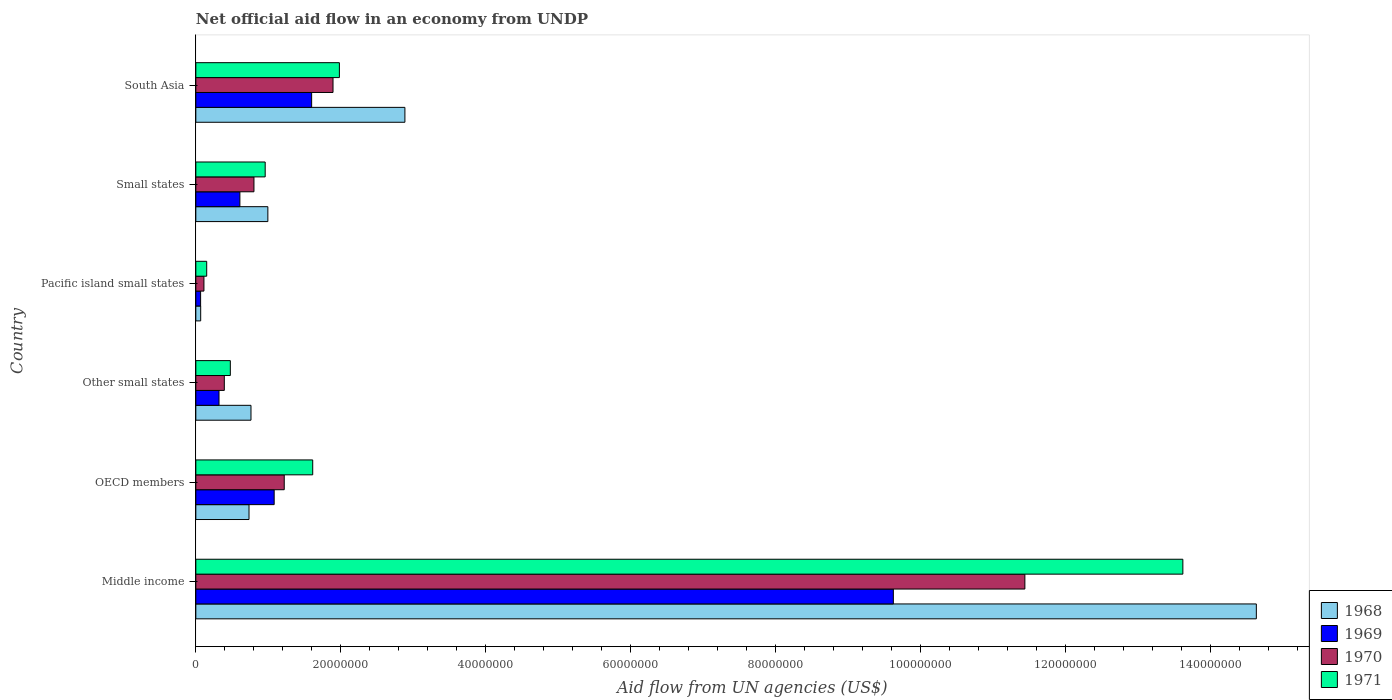How many different coloured bars are there?
Offer a terse response. 4. How many groups of bars are there?
Offer a terse response. 6. Are the number of bars per tick equal to the number of legend labels?
Make the answer very short. Yes. Are the number of bars on each tick of the Y-axis equal?
Make the answer very short. Yes. How many bars are there on the 2nd tick from the bottom?
Keep it short and to the point. 4. What is the label of the 5th group of bars from the top?
Your answer should be very brief. OECD members. What is the net official aid flow in 1968 in OECD members?
Your answer should be compact. 7.34e+06. Across all countries, what is the maximum net official aid flow in 1968?
Provide a succinct answer. 1.46e+08. Across all countries, what is the minimum net official aid flow in 1968?
Your answer should be very brief. 6.70e+05. In which country was the net official aid flow in 1970 maximum?
Give a very brief answer. Middle income. In which country was the net official aid flow in 1969 minimum?
Offer a very short reply. Pacific island small states. What is the total net official aid flow in 1971 in the graph?
Provide a short and direct response. 1.88e+08. What is the difference between the net official aid flow in 1970 in OECD members and that in Other small states?
Offer a terse response. 8.27e+06. What is the difference between the net official aid flow in 1971 in Pacific island small states and the net official aid flow in 1970 in Middle income?
Offer a very short reply. -1.13e+08. What is the average net official aid flow in 1970 per country?
Your answer should be compact. 2.64e+07. What is the difference between the net official aid flow in 1971 and net official aid flow in 1968 in Small states?
Provide a succinct answer. -3.70e+05. What is the ratio of the net official aid flow in 1969 in Pacific island small states to that in South Asia?
Your answer should be compact. 0.04. Is the net official aid flow in 1968 in OECD members less than that in Small states?
Give a very brief answer. Yes. Is the difference between the net official aid flow in 1971 in OECD members and Pacific island small states greater than the difference between the net official aid flow in 1968 in OECD members and Pacific island small states?
Your answer should be very brief. Yes. What is the difference between the highest and the second highest net official aid flow in 1971?
Give a very brief answer. 1.16e+08. What is the difference between the highest and the lowest net official aid flow in 1968?
Make the answer very short. 1.46e+08. In how many countries, is the net official aid flow in 1968 greater than the average net official aid flow in 1968 taken over all countries?
Make the answer very short. 1. Is the sum of the net official aid flow in 1969 in Other small states and Pacific island small states greater than the maximum net official aid flow in 1968 across all countries?
Your response must be concise. No. What does the 2nd bar from the bottom in Middle income represents?
Ensure brevity in your answer.  1969. Is it the case that in every country, the sum of the net official aid flow in 1971 and net official aid flow in 1970 is greater than the net official aid flow in 1968?
Give a very brief answer. Yes. What is the difference between two consecutive major ticks on the X-axis?
Your answer should be very brief. 2.00e+07. Does the graph contain any zero values?
Make the answer very short. No. Does the graph contain grids?
Ensure brevity in your answer.  No. Where does the legend appear in the graph?
Your response must be concise. Bottom right. How many legend labels are there?
Offer a terse response. 4. What is the title of the graph?
Offer a very short reply. Net official aid flow in an economy from UNDP. What is the label or title of the X-axis?
Keep it short and to the point. Aid flow from UN agencies (US$). What is the label or title of the Y-axis?
Keep it short and to the point. Country. What is the Aid flow from UN agencies (US$) of 1968 in Middle income?
Provide a succinct answer. 1.46e+08. What is the Aid flow from UN agencies (US$) of 1969 in Middle income?
Ensure brevity in your answer.  9.62e+07. What is the Aid flow from UN agencies (US$) of 1970 in Middle income?
Give a very brief answer. 1.14e+08. What is the Aid flow from UN agencies (US$) of 1971 in Middle income?
Keep it short and to the point. 1.36e+08. What is the Aid flow from UN agencies (US$) of 1968 in OECD members?
Offer a terse response. 7.34e+06. What is the Aid flow from UN agencies (US$) in 1969 in OECD members?
Provide a succinct answer. 1.08e+07. What is the Aid flow from UN agencies (US$) of 1970 in OECD members?
Provide a short and direct response. 1.22e+07. What is the Aid flow from UN agencies (US$) of 1971 in OECD members?
Offer a terse response. 1.61e+07. What is the Aid flow from UN agencies (US$) in 1968 in Other small states?
Give a very brief answer. 7.61e+06. What is the Aid flow from UN agencies (US$) in 1969 in Other small states?
Your answer should be compact. 3.20e+06. What is the Aid flow from UN agencies (US$) in 1970 in Other small states?
Keep it short and to the point. 3.93e+06. What is the Aid flow from UN agencies (US$) of 1971 in Other small states?
Provide a succinct answer. 4.76e+06. What is the Aid flow from UN agencies (US$) of 1968 in Pacific island small states?
Ensure brevity in your answer.  6.70e+05. What is the Aid flow from UN agencies (US$) of 1970 in Pacific island small states?
Provide a succinct answer. 1.12e+06. What is the Aid flow from UN agencies (US$) of 1971 in Pacific island small states?
Your response must be concise. 1.50e+06. What is the Aid flow from UN agencies (US$) in 1968 in Small states?
Offer a terse response. 9.94e+06. What is the Aid flow from UN agencies (US$) in 1969 in Small states?
Provide a succinct answer. 6.08e+06. What is the Aid flow from UN agencies (US$) in 1970 in Small states?
Ensure brevity in your answer.  8.02e+06. What is the Aid flow from UN agencies (US$) in 1971 in Small states?
Provide a succinct answer. 9.57e+06. What is the Aid flow from UN agencies (US$) of 1968 in South Asia?
Your answer should be compact. 2.88e+07. What is the Aid flow from UN agencies (US$) in 1969 in South Asia?
Provide a succinct answer. 1.60e+07. What is the Aid flow from UN agencies (US$) in 1970 in South Asia?
Your answer should be compact. 1.89e+07. What is the Aid flow from UN agencies (US$) in 1971 in South Asia?
Make the answer very short. 1.98e+07. Across all countries, what is the maximum Aid flow from UN agencies (US$) in 1968?
Provide a succinct answer. 1.46e+08. Across all countries, what is the maximum Aid flow from UN agencies (US$) in 1969?
Ensure brevity in your answer.  9.62e+07. Across all countries, what is the maximum Aid flow from UN agencies (US$) of 1970?
Ensure brevity in your answer.  1.14e+08. Across all countries, what is the maximum Aid flow from UN agencies (US$) of 1971?
Make the answer very short. 1.36e+08. Across all countries, what is the minimum Aid flow from UN agencies (US$) in 1968?
Offer a very short reply. 6.70e+05. Across all countries, what is the minimum Aid flow from UN agencies (US$) in 1969?
Your answer should be very brief. 6.60e+05. Across all countries, what is the minimum Aid flow from UN agencies (US$) in 1970?
Give a very brief answer. 1.12e+06. Across all countries, what is the minimum Aid flow from UN agencies (US$) of 1971?
Your answer should be compact. 1.50e+06. What is the total Aid flow from UN agencies (US$) of 1968 in the graph?
Your answer should be compact. 2.01e+08. What is the total Aid flow from UN agencies (US$) of 1969 in the graph?
Offer a very short reply. 1.33e+08. What is the total Aid flow from UN agencies (US$) in 1970 in the graph?
Your answer should be compact. 1.59e+08. What is the total Aid flow from UN agencies (US$) in 1971 in the graph?
Your response must be concise. 1.88e+08. What is the difference between the Aid flow from UN agencies (US$) of 1968 in Middle income and that in OECD members?
Provide a short and direct response. 1.39e+08. What is the difference between the Aid flow from UN agencies (US$) of 1969 in Middle income and that in OECD members?
Give a very brief answer. 8.54e+07. What is the difference between the Aid flow from UN agencies (US$) of 1970 in Middle income and that in OECD members?
Give a very brief answer. 1.02e+08. What is the difference between the Aid flow from UN agencies (US$) of 1971 in Middle income and that in OECD members?
Make the answer very short. 1.20e+08. What is the difference between the Aid flow from UN agencies (US$) of 1968 in Middle income and that in Other small states?
Offer a terse response. 1.39e+08. What is the difference between the Aid flow from UN agencies (US$) in 1969 in Middle income and that in Other small states?
Give a very brief answer. 9.30e+07. What is the difference between the Aid flow from UN agencies (US$) of 1970 in Middle income and that in Other small states?
Ensure brevity in your answer.  1.10e+08. What is the difference between the Aid flow from UN agencies (US$) in 1971 in Middle income and that in Other small states?
Keep it short and to the point. 1.31e+08. What is the difference between the Aid flow from UN agencies (US$) in 1968 in Middle income and that in Pacific island small states?
Offer a very short reply. 1.46e+08. What is the difference between the Aid flow from UN agencies (US$) of 1969 in Middle income and that in Pacific island small states?
Keep it short and to the point. 9.56e+07. What is the difference between the Aid flow from UN agencies (US$) of 1970 in Middle income and that in Pacific island small states?
Keep it short and to the point. 1.13e+08. What is the difference between the Aid flow from UN agencies (US$) in 1971 in Middle income and that in Pacific island small states?
Offer a terse response. 1.35e+08. What is the difference between the Aid flow from UN agencies (US$) in 1968 in Middle income and that in Small states?
Your answer should be compact. 1.36e+08. What is the difference between the Aid flow from UN agencies (US$) in 1969 in Middle income and that in Small states?
Ensure brevity in your answer.  9.02e+07. What is the difference between the Aid flow from UN agencies (US$) in 1970 in Middle income and that in Small states?
Provide a short and direct response. 1.06e+08. What is the difference between the Aid flow from UN agencies (US$) in 1971 in Middle income and that in Small states?
Offer a terse response. 1.27e+08. What is the difference between the Aid flow from UN agencies (US$) in 1968 in Middle income and that in South Asia?
Your answer should be very brief. 1.17e+08. What is the difference between the Aid flow from UN agencies (US$) in 1969 in Middle income and that in South Asia?
Make the answer very short. 8.03e+07. What is the difference between the Aid flow from UN agencies (US$) of 1970 in Middle income and that in South Asia?
Your answer should be very brief. 9.55e+07. What is the difference between the Aid flow from UN agencies (US$) of 1971 in Middle income and that in South Asia?
Your answer should be compact. 1.16e+08. What is the difference between the Aid flow from UN agencies (US$) of 1969 in OECD members and that in Other small states?
Provide a succinct answer. 7.61e+06. What is the difference between the Aid flow from UN agencies (US$) in 1970 in OECD members and that in Other small states?
Offer a very short reply. 8.27e+06. What is the difference between the Aid flow from UN agencies (US$) in 1971 in OECD members and that in Other small states?
Your answer should be compact. 1.14e+07. What is the difference between the Aid flow from UN agencies (US$) of 1968 in OECD members and that in Pacific island small states?
Ensure brevity in your answer.  6.67e+06. What is the difference between the Aid flow from UN agencies (US$) in 1969 in OECD members and that in Pacific island small states?
Offer a very short reply. 1.02e+07. What is the difference between the Aid flow from UN agencies (US$) of 1970 in OECD members and that in Pacific island small states?
Offer a terse response. 1.11e+07. What is the difference between the Aid flow from UN agencies (US$) of 1971 in OECD members and that in Pacific island small states?
Your answer should be compact. 1.46e+07. What is the difference between the Aid flow from UN agencies (US$) in 1968 in OECD members and that in Small states?
Your answer should be very brief. -2.60e+06. What is the difference between the Aid flow from UN agencies (US$) in 1969 in OECD members and that in Small states?
Provide a succinct answer. 4.73e+06. What is the difference between the Aid flow from UN agencies (US$) in 1970 in OECD members and that in Small states?
Your answer should be very brief. 4.18e+06. What is the difference between the Aid flow from UN agencies (US$) of 1971 in OECD members and that in Small states?
Offer a terse response. 6.56e+06. What is the difference between the Aid flow from UN agencies (US$) in 1968 in OECD members and that in South Asia?
Provide a succinct answer. -2.15e+07. What is the difference between the Aid flow from UN agencies (US$) in 1969 in OECD members and that in South Asia?
Your answer should be very brief. -5.17e+06. What is the difference between the Aid flow from UN agencies (US$) in 1970 in OECD members and that in South Asia?
Your answer should be very brief. -6.73e+06. What is the difference between the Aid flow from UN agencies (US$) of 1971 in OECD members and that in South Asia?
Provide a short and direct response. -3.68e+06. What is the difference between the Aid flow from UN agencies (US$) of 1968 in Other small states and that in Pacific island small states?
Your answer should be compact. 6.94e+06. What is the difference between the Aid flow from UN agencies (US$) of 1969 in Other small states and that in Pacific island small states?
Make the answer very short. 2.54e+06. What is the difference between the Aid flow from UN agencies (US$) of 1970 in Other small states and that in Pacific island small states?
Your answer should be very brief. 2.81e+06. What is the difference between the Aid flow from UN agencies (US$) of 1971 in Other small states and that in Pacific island small states?
Make the answer very short. 3.26e+06. What is the difference between the Aid flow from UN agencies (US$) in 1968 in Other small states and that in Small states?
Your answer should be compact. -2.33e+06. What is the difference between the Aid flow from UN agencies (US$) in 1969 in Other small states and that in Small states?
Offer a very short reply. -2.88e+06. What is the difference between the Aid flow from UN agencies (US$) of 1970 in Other small states and that in Small states?
Provide a short and direct response. -4.09e+06. What is the difference between the Aid flow from UN agencies (US$) in 1971 in Other small states and that in Small states?
Provide a succinct answer. -4.81e+06. What is the difference between the Aid flow from UN agencies (US$) in 1968 in Other small states and that in South Asia?
Ensure brevity in your answer.  -2.12e+07. What is the difference between the Aid flow from UN agencies (US$) in 1969 in Other small states and that in South Asia?
Ensure brevity in your answer.  -1.28e+07. What is the difference between the Aid flow from UN agencies (US$) in 1970 in Other small states and that in South Asia?
Give a very brief answer. -1.50e+07. What is the difference between the Aid flow from UN agencies (US$) in 1971 in Other small states and that in South Asia?
Your answer should be compact. -1.50e+07. What is the difference between the Aid flow from UN agencies (US$) of 1968 in Pacific island small states and that in Small states?
Ensure brevity in your answer.  -9.27e+06. What is the difference between the Aid flow from UN agencies (US$) in 1969 in Pacific island small states and that in Small states?
Your answer should be compact. -5.42e+06. What is the difference between the Aid flow from UN agencies (US$) in 1970 in Pacific island small states and that in Small states?
Make the answer very short. -6.90e+06. What is the difference between the Aid flow from UN agencies (US$) of 1971 in Pacific island small states and that in Small states?
Give a very brief answer. -8.07e+06. What is the difference between the Aid flow from UN agencies (US$) in 1968 in Pacific island small states and that in South Asia?
Offer a terse response. -2.82e+07. What is the difference between the Aid flow from UN agencies (US$) in 1969 in Pacific island small states and that in South Asia?
Give a very brief answer. -1.53e+07. What is the difference between the Aid flow from UN agencies (US$) in 1970 in Pacific island small states and that in South Asia?
Give a very brief answer. -1.78e+07. What is the difference between the Aid flow from UN agencies (US$) in 1971 in Pacific island small states and that in South Asia?
Provide a succinct answer. -1.83e+07. What is the difference between the Aid flow from UN agencies (US$) in 1968 in Small states and that in South Asia?
Your answer should be compact. -1.89e+07. What is the difference between the Aid flow from UN agencies (US$) in 1969 in Small states and that in South Asia?
Keep it short and to the point. -9.90e+06. What is the difference between the Aid flow from UN agencies (US$) of 1970 in Small states and that in South Asia?
Give a very brief answer. -1.09e+07. What is the difference between the Aid flow from UN agencies (US$) in 1971 in Small states and that in South Asia?
Provide a succinct answer. -1.02e+07. What is the difference between the Aid flow from UN agencies (US$) of 1968 in Middle income and the Aid flow from UN agencies (US$) of 1969 in OECD members?
Provide a succinct answer. 1.36e+08. What is the difference between the Aid flow from UN agencies (US$) in 1968 in Middle income and the Aid flow from UN agencies (US$) in 1970 in OECD members?
Your answer should be very brief. 1.34e+08. What is the difference between the Aid flow from UN agencies (US$) in 1968 in Middle income and the Aid flow from UN agencies (US$) in 1971 in OECD members?
Offer a very short reply. 1.30e+08. What is the difference between the Aid flow from UN agencies (US$) of 1969 in Middle income and the Aid flow from UN agencies (US$) of 1970 in OECD members?
Provide a short and direct response. 8.40e+07. What is the difference between the Aid flow from UN agencies (US$) of 1969 in Middle income and the Aid flow from UN agencies (US$) of 1971 in OECD members?
Keep it short and to the point. 8.01e+07. What is the difference between the Aid flow from UN agencies (US$) of 1970 in Middle income and the Aid flow from UN agencies (US$) of 1971 in OECD members?
Give a very brief answer. 9.83e+07. What is the difference between the Aid flow from UN agencies (US$) of 1968 in Middle income and the Aid flow from UN agencies (US$) of 1969 in Other small states?
Provide a succinct answer. 1.43e+08. What is the difference between the Aid flow from UN agencies (US$) in 1968 in Middle income and the Aid flow from UN agencies (US$) in 1970 in Other small states?
Your response must be concise. 1.42e+08. What is the difference between the Aid flow from UN agencies (US$) in 1968 in Middle income and the Aid flow from UN agencies (US$) in 1971 in Other small states?
Provide a short and direct response. 1.42e+08. What is the difference between the Aid flow from UN agencies (US$) of 1969 in Middle income and the Aid flow from UN agencies (US$) of 1970 in Other small states?
Provide a short and direct response. 9.23e+07. What is the difference between the Aid flow from UN agencies (US$) of 1969 in Middle income and the Aid flow from UN agencies (US$) of 1971 in Other small states?
Keep it short and to the point. 9.15e+07. What is the difference between the Aid flow from UN agencies (US$) of 1970 in Middle income and the Aid flow from UN agencies (US$) of 1971 in Other small states?
Provide a succinct answer. 1.10e+08. What is the difference between the Aid flow from UN agencies (US$) in 1968 in Middle income and the Aid flow from UN agencies (US$) in 1969 in Pacific island small states?
Your answer should be very brief. 1.46e+08. What is the difference between the Aid flow from UN agencies (US$) in 1968 in Middle income and the Aid flow from UN agencies (US$) in 1970 in Pacific island small states?
Make the answer very short. 1.45e+08. What is the difference between the Aid flow from UN agencies (US$) of 1968 in Middle income and the Aid flow from UN agencies (US$) of 1971 in Pacific island small states?
Offer a very short reply. 1.45e+08. What is the difference between the Aid flow from UN agencies (US$) of 1969 in Middle income and the Aid flow from UN agencies (US$) of 1970 in Pacific island small states?
Ensure brevity in your answer.  9.51e+07. What is the difference between the Aid flow from UN agencies (US$) in 1969 in Middle income and the Aid flow from UN agencies (US$) in 1971 in Pacific island small states?
Offer a very short reply. 9.48e+07. What is the difference between the Aid flow from UN agencies (US$) in 1970 in Middle income and the Aid flow from UN agencies (US$) in 1971 in Pacific island small states?
Your response must be concise. 1.13e+08. What is the difference between the Aid flow from UN agencies (US$) in 1968 in Middle income and the Aid flow from UN agencies (US$) in 1969 in Small states?
Your answer should be compact. 1.40e+08. What is the difference between the Aid flow from UN agencies (US$) in 1968 in Middle income and the Aid flow from UN agencies (US$) in 1970 in Small states?
Ensure brevity in your answer.  1.38e+08. What is the difference between the Aid flow from UN agencies (US$) of 1968 in Middle income and the Aid flow from UN agencies (US$) of 1971 in Small states?
Offer a very short reply. 1.37e+08. What is the difference between the Aid flow from UN agencies (US$) of 1969 in Middle income and the Aid flow from UN agencies (US$) of 1970 in Small states?
Provide a succinct answer. 8.82e+07. What is the difference between the Aid flow from UN agencies (US$) of 1969 in Middle income and the Aid flow from UN agencies (US$) of 1971 in Small states?
Your response must be concise. 8.67e+07. What is the difference between the Aid flow from UN agencies (US$) in 1970 in Middle income and the Aid flow from UN agencies (US$) in 1971 in Small states?
Offer a terse response. 1.05e+08. What is the difference between the Aid flow from UN agencies (US$) of 1968 in Middle income and the Aid flow from UN agencies (US$) of 1969 in South Asia?
Provide a short and direct response. 1.30e+08. What is the difference between the Aid flow from UN agencies (US$) of 1968 in Middle income and the Aid flow from UN agencies (US$) of 1970 in South Asia?
Provide a succinct answer. 1.27e+08. What is the difference between the Aid flow from UN agencies (US$) of 1968 in Middle income and the Aid flow from UN agencies (US$) of 1971 in South Asia?
Your response must be concise. 1.27e+08. What is the difference between the Aid flow from UN agencies (US$) of 1969 in Middle income and the Aid flow from UN agencies (US$) of 1970 in South Asia?
Offer a very short reply. 7.73e+07. What is the difference between the Aid flow from UN agencies (US$) of 1969 in Middle income and the Aid flow from UN agencies (US$) of 1971 in South Asia?
Offer a very short reply. 7.64e+07. What is the difference between the Aid flow from UN agencies (US$) of 1970 in Middle income and the Aid flow from UN agencies (US$) of 1971 in South Asia?
Ensure brevity in your answer.  9.46e+07. What is the difference between the Aid flow from UN agencies (US$) in 1968 in OECD members and the Aid flow from UN agencies (US$) in 1969 in Other small states?
Ensure brevity in your answer.  4.14e+06. What is the difference between the Aid flow from UN agencies (US$) of 1968 in OECD members and the Aid flow from UN agencies (US$) of 1970 in Other small states?
Offer a terse response. 3.41e+06. What is the difference between the Aid flow from UN agencies (US$) of 1968 in OECD members and the Aid flow from UN agencies (US$) of 1971 in Other small states?
Keep it short and to the point. 2.58e+06. What is the difference between the Aid flow from UN agencies (US$) of 1969 in OECD members and the Aid flow from UN agencies (US$) of 1970 in Other small states?
Your answer should be very brief. 6.88e+06. What is the difference between the Aid flow from UN agencies (US$) in 1969 in OECD members and the Aid flow from UN agencies (US$) in 1971 in Other small states?
Make the answer very short. 6.05e+06. What is the difference between the Aid flow from UN agencies (US$) of 1970 in OECD members and the Aid flow from UN agencies (US$) of 1971 in Other small states?
Your response must be concise. 7.44e+06. What is the difference between the Aid flow from UN agencies (US$) of 1968 in OECD members and the Aid flow from UN agencies (US$) of 1969 in Pacific island small states?
Ensure brevity in your answer.  6.68e+06. What is the difference between the Aid flow from UN agencies (US$) in 1968 in OECD members and the Aid flow from UN agencies (US$) in 1970 in Pacific island small states?
Offer a terse response. 6.22e+06. What is the difference between the Aid flow from UN agencies (US$) of 1968 in OECD members and the Aid flow from UN agencies (US$) of 1971 in Pacific island small states?
Offer a terse response. 5.84e+06. What is the difference between the Aid flow from UN agencies (US$) of 1969 in OECD members and the Aid flow from UN agencies (US$) of 1970 in Pacific island small states?
Your response must be concise. 9.69e+06. What is the difference between the Aid flow from UN agencies (US$) of 1969 in OECD members and the Aid flow from UN agencies (US$) of 1971 in Pacific island small states?
Offer a very short reply. 9.31e+06. What is the difference between the Aid flow from UN agencies (US$) of 1970 in OECD members and the Aid flow from UN agencies (US$) of 1971 in Pacific island small states?
Offer a very short reply. 1.07e+07. What is the difference between the Aid flow from UN agencies (US$) in 1968 in OECD members and the Aid flow from UN agencies (US$) in 1969 in Small states?
Provide a short and direct response. 1.26e+06. What is the difference between the Aid flow from UN agencies (US$) of 1968 in OECD members and the Aid flow from UN agencies (US$) of 1970 in Small states?
Provide a short and direct response. -6.80e+05. What is the difference between the Aid flow from UN agencies (US$) of 1968 in OECD members and the Aid flow from UN agencies (US$) of 1971 in Small states?
Provide a succinct answer. -2.23e+06. What is the difference between the Aid flow from UN agencies (US$) of 1969 in OECD members and the Aid flow from UN agencies (US$) of 1970 in Small states?
Ensure brevity in your answer.  2.79e+06. What is the difference between the Aid flow from UN agencies (US$) of 1969 in OECD members and the Aid flow from UN agencies (US$) of 1971 in Small states?
Keep it short and to the point. 1.24e+06. What is the difference between the Aid flow from UN agencies (US$) in 1970 in OECD members and the Aid flow from UN agencies (US$) in 1971 in Small states?
Offer a very short reply. 2.63e+06. What is the difference between the Aid flow from UN agencies (US$) in 1968 in OECD members and the Aid flow from UN agencies (US$) in 1969 in South Asia?
Keep it short and to the point. -8.64e+06. What is the difference between the Aid flow from UN agencies (US$) in 1968 in OECD members and the Aid flow from UN agencies (US$) in 1970 in South Asia?
Give a very brief answer. -1.16e+07. What is the difference between the Aid flow from UN agencies (US$) of 1968 in OECD members and the Aid flow from UN agencies (US$) of 1971 in South Asia?
Your answer should be compact. -1.25e+07. What is the difference between the Aid flow from UN agencies (US$) of 1969 in OECD members and the Aid flow from UN agencies (US$) of 1970 in South Asia?
Keep it short and to the point. -8.12e+06. What is the difference between the Aid flow from UN agencies (US$) in 1969 in OECD members and the Aid flow from UN agencies (US$) in 1971 in South Asia?
Provide a succinct answer. -9.00e+06. What is the difference between the Aid flow from UN agencies (US$) in 1970 in OECD members and the Aid flow from UN agencies (US$) in 1971 in South Asia?
Make the answer very short. -7.61e+06. What is the difference between the Aid flow from UN agencies (US$) in 1968 in Other small states and the Aid flow from UN agencies (US$) in 1969 in Pacific island small states?
Provide a short and direct response. 6.95e+06. What is the difference between the Aid flow from UN agencies (US$) in 1968 in Other small states and the Aid flow from UN agencies (US$) in 1970 in Pacific island small states?
Provide a succinct answer. 6.49e+06. What is the difference between the Aid flow from UN agencies (US$) of 1968 in Other small states and the Aid flow from UN agencies (US$) of 1971 in Pacific island small states?
Your answer should be very brief. 6.11e+06. What is the difference between the Aid flow from UN agencies (US$) of 1969 in Other small states and the Aid flow from UN agencies (US$) of 1970 in Pacific island small states?
Provide a short and direct response. 2.08e+06. What is the difference between the Aid flow from UN agencies (US$) in 1969 in Other small states and the Aid flow from UN agencies (US$) in 1971 in Pacific island small states?
Give a very brief answer. 1.70e+06. What is the difference between the Aid flow from UN agencies (US$) of 1970 in Other small states and the Aid flow from UN agencies (US$) of 1971 in Pacific island small states?
Ensure brevity in your answer.  2.43e+06. What is the difference between the Aid flow from UN agencies (US$) in 1968 in Other small states and the Aid flow from UN agencies (US$) in 1969 in Small states?
Keep it short and to the point. 1.53e+06. What is the difference between the Aid flow from UN agencies (US$) of 1968 in Other small states and the Aid flow from UN agencies (US$) of 1970 in Small states?
Keep it short and to the point. -4.10e+05. What is the difference between the Aid flow from UN agencies (US$) in 1968 in Other small states and the Aid flow from UN agencies (US$) in 1971 in Small states?
Your response must be concise. -1.96e+06. What is the difference between the Aid flow from UN agencies (US$) in 1969 in Other small states and the Aid flow from UN agencies (US$) in 1970 in Small states?
Keep it short and to the point. -4.82e+06. What is the difference between the Aid flow from UN agencies (US$) in 1969 in Other small states and the Aid flow from UN agencies (US$) in 1971 in Small states?
Keep it short and to the point. -6.37e+06. What is the difference between the Aid flow from UN agencies (US$) in 1970 in Other small states and the Aid flow from UN agencies (US$) in 1971 in Small states?
Give a very brief answer. -5.64e+06. What is the difference between the Aid flow from UN agencies (US$) of 1968 in Other small states and the Aid flow from UN agencies (US$) of 1969 in South Asia?
Make the answer very short. -8.37e+06. What is the difference between the Aid flow from UN agencies (US$) of 1968 in Other small states and the Aid flow from UN agencies (US$) of 1970 in South Asia?
Make the answer very short. -1.13e+07. What is the difference between the Aid flow from UN agencies (US$) of 1968 in Other small states and the Aid flow from UN agencies (US$) of 1971 in South Asia?
Ensure brevity in your answer.  -1.22e+07. What is the difference between the Aid flow from UN agencies (US$) of 1969 in Other small states and the Aid flow from UN agencies (US$) of 1970 in South Asia?
Offer a very short reply. -1.57e+07. What is the difference between the Aid flow from UN agencies (US$) in 1969 in Other small states and the Aid flow from UN agencies (US$) in 1971 in South Asia?
Give a very brief answer. -1.66e+07. What is the difference between the Aid flow from UN agencies (US$) of 1970 in Other small states and the Aid flow from UN agencies (US$) of 1971 in South Asia?
Provide a succinct answer. -1.59e+07. What is the difference between the Aid flow from UN agencies (US$) of 1968 in Pacific island small states and the Aid flow from UN agencies (US$) of 1969 in Small states?
Provide a succinct answer. -5.41e+06. What is the difference between the Aid flow from UN agencies (US$) in 1968 in Pacific island small states and the Aid flow from UN agencies (US$) in 1970 in Small states?
Provide a succinct answer. -7.35e+06. What is the difference between the Aid flow from UN agencies (US$) in 1968 in Pacific island small states and the Aid flow from UN agencies (US$) in 1971 in Small states?
Your answer should be compact. -8.90e+06. What is the difference between the Aid flow from UN agencies (US$) of 1969 in Pacific island small states and the Aid flow from UN agencies (US$) of 1970 in Small states?
Your answer should be very brief. -7.36e+06. What is the difference between the Aid flow from UN agencies (US$) in 1969 in Pacific island small states and the Aid flow from UN agencies (US$) in 1971 in Small states?
Offer a terse response. -8.91e+06. What is the difference between the Aid flow from UN agencies (US$) in 1970 in Pacific island small states and the Aid flow from UN agencies (US$) in 1971 in Small states?
Ensure brevity in your answer.  -8.45e+06. What is the difference between the Aid flow from UN agencies (US$) in 1968 in Pacific island small states and the Aid flow from UN agencies (US$) in 1969 in South Asia?
Provide a succinct answer. -1.53e+07. What is the difference between the Aid flow from UN agencies (US$) of 1968 in Pacific island small states and the Aid flow from UN agencies (US$) of 1970 in South Asia?
Keep it short and to the point. -1.83e+07. What is the difference between the Aid flow from UN agencies (US$) of 1968 in Pacific island small states and the Aid flow from UN agencies (US$) of 1971 in South Asia?
Give a very brief answer. -1.91e+07. What is the difference between the Aid flow from UN agencies (US$) in 1969 in Pacific island small states and the Aid flow from UN agencies (US$) in 1970 in South Asia?
Offer a very short reply. -1.83e+07. What is the difference between the Aid flow from UN agencies (US$) in 1969 in Pacific island small states and the Aid flow from UN agencies (US$) in 1971 in South Asia?
Your answer should be compact. -1.92e+07. What is the difference between the Aid flow from UN agencies (US$) in 1970 in Pacific island small states and the Aid flow from UN agencies (US$) in 1971 in South Asia?
Your response must be concise. -1.87e+07. What is the difference between the Aid flow from UN agencies (US$) of 1968 in Small states and the Aid flow from UN agencies (US$) of 1969 in South Asia?
Your answer should be compact. -6.04e+06. What is the difference between the Aid flow from UN agencies (US$) of 1968 in Small states and the Aid flow from UN agencies (US$) of 1970 in South Asia?
Your answer should be very brief. -8.99e+06. What is the difference between the Aid flow from UN agencies (US$) in 1968 in Small states and the Aid flow from UN agencies (US$) in 1971 in South Asia?
Provide a succinct answer. -9.87e+06. What is the difference between the Aid flow from UN agencies (US$) of 1969 in Small states and the Aid flow from UN agencies (US$) of 1970 in South Asia?
Keep it short and to the point. -1.28e+07. What is the difference between the Aid flow from UN agencies (US$) of 1969 in Small states and the Aid flow from UN agencies (US$) of 1971 in South Asia?
Provide a short and direct response. -1.37e+07. What is the difference between the Aid flow from UN agencies (US$) of 1970 in Small states and the Aid flow from UN agencies (US$) of 1971 in South Asia?
Ensure brevity in your answer.  -1.18e+07. What is the average Aid flow from UN agencies (US$) of 1968 per country?
Provide a short and direct response. 3.35e+07. What is the average Aid flow from UN agencies (US$) in 1969 per country?
Give a very brief answer. 2.22e+07. What is the average Aid flow from UN agencies (US$) of 1970 per country?
Keep it short and to the point. 2.64e+07. What is the average Aid flow from UN agencies (US$) of 1971 per country?
Give a very brief answer. 3.13e+07. What is the difference between the Aid flow from UN agencies (US$) in 1968 and Aid flow from UN agencies (US$) in 1969 in Middle income?
Offer a very short reply. 5.01e+07. What is the difference between the Aid flow from UN agencies (US$) in 1968 and Aid flow from UN agencies (US$) in 1970 in Middle income?
Provide a short and direct response. 3.19e+07. What is the difference between the Aid flow from UN agencies (US$) in 1968 and Aid flow from UN agencies (US$) in 1971 in Middle income?
Provide a short and direct response. 1.01e+07. What is the difference between the Aid flow from UN agencies (US$) in 1969 and Aid flow from UN agencies (US$) in 1970 in Middle income?
Your answer should be very brief. -1.82e+07. What is the difference between the Aid flow from UN agencies (US$) of 1969 and Aid flow from UN agencies (US$) of 1971 in Middle income?
Offer a very short reply. -4.00e+07. What is the difference between the Aid flow from UN agencies (US$) of 1970 and Aid flow from UN agencies (US$) of 1971 in Middle income?
Provide a short and direct response. -2.18e+07. What is the difference between the Aid flow from UN agencies (US$) in 1968 and Aid flow from UN agencies (US$) in 1969 in OECD members?
Offer a very short reply. -3.47e+06. What is the difference between the Aid flow from UN agencies (US$) in 1968 and Aid flow from UN agencies (US$) in 1970 in OECD members?
Provide a short and direct response. -4.86e+06. What is the difference between the Aid flow from UN agencies (US$) in 1968 and Aid flow from UN agencies (US$) in 1971 in OECD members?
Your answer should be compact. -8.79e+06. What is the difference between the Aid flow from UN agencies (US$) of 1969 and Aid flow from UN agencies (US$) of 1970 in OECD members?
Offer a very short reply. -1.39e+06. What is the difference between the Aid flow from UN agencies (US$) in 1969 and Aid flow from UN agencies (US$) in 1971 in OECD members?
Make the answer very short. -5.32e+06. What is the difference between the Aid flow from UN agencies (US$) of 1970 and Aid flow from UN agencies (US$) of 1971 in OECD members?
Ensure brevity in your answer.  -3.93e+06. What is the difference between the Aid flow from UN agencies (US$) in 1968 and Aid flow from UN agencies (US$) in 1969 in Other small states?
Your answer should be very brief. 4.41e+06. What is the difference between the Aid flow from UN agencies (US$) in 1968 and Aid flow from UN agencies (US$) in 1970 in Other small states?
Ensure brevity in your answer.  3.68e+06. What is the difference between the Aid flow from UN agencies (US$) of 1968 and Aid flow from UN agencies (US$) of 1971 in Other small states?
Provide a short and direct response. 2.85e+06. What is the difference between the Aid flow from UN agencies (US$) in 1969 and Aid flow from UN agencies (US$) in 1970 in Other small states?
Ensure brevity in your answer.  -7.30e+05. What is the difference between the Aid flow from UN agencies (US$) in 1969 and Aid flow from UN agencies (US$) in 1971 in Other small states?
Make the answer very short. -1.56e+06. What is the difference between the Aid flow from UN agencies (US$) in 1970 and Aid flow from UN agencies (US$) in 1971 in Other small states?
Your answer should be compact. -8.30e+05. What is the difference between the Aid flow from UN agencies (US$) of 1968 and Aid flow from UN agencies (US$) of 1970 in Pacific island small states?
Your answer should be compact. -4.50e+05. What is the difference between the Aid flow from UN agencies (US$) of 1968 and Aid flow from UN agencies (US$) of 1971 in Pacific island small states?
Your response must be concise. -8.30e+05. What is the difference between the Aid flow from UN agencies (US$) in 1969 and Aid flow from UN agencies (US$) in 1970 in Pacific island small states?
Your response must be concise. -4.60e+05. What is the difference between the Aid flow from UN agencies (US$) of 1969 and Aid flow from UN agencies (US$) of 1971 in Pacific island small states?
Provide a short and direct response. -8.40e+05. What is the difference between the Aid flow from UN agencies (US$) of 1970 and Aid flow from UN agencies (US$) of 1971 in Pacific island small states?
Provide a short and direct response. -3.80e+05. What is the difference between the Aid flow from UN agencies (US$) in 1968 and Aid flow from UN agencies (US$) in 1969 in Small states?
Ensure brevity in your answer.  3.86e+06. What is the difference between the Aid flow from UN agencies (US$) of 1968 and Aid flow from UN agencies (US$) of 1970 in Small states?
Offer a very short reply. 1.92e+06. What is the difference between the Aid flow from UN agencies (US$) in 1969 and Aid flow from UN agencies (US$) in 1970 in Small states?
Ensure brevity in your answer.  -1.94e+06. What is the difference between the Aid flow from UN agencies (US$) of 1969 and Aid flow from UN agencies (US$) of 1971 in Small states?
Ensure brevity in your answer.  -3.49e+06. What is the difference between the Aid flow from UN agencies (US$) of 1970 and Aid flow from UN agencies (US$) of 1971 in Small states?
Offer a terse response. -1.55e+06. What is the difference between the Aid flow from UN agencies (US$) of 1968 and Aid flow from UN agencies (US$) of 1969 in South Asia?
Make the answer very short. 1.29e+07. What is the difference between the Aid flow from UN agencies (US$) of 1968 and Aid flow from UN agencies (US$) of 1970 in South Asia?
Your response must be concise. 9.92e+06. What is the difference between the Aid flow from UN agencies (US$) of 1968 and Aid flow from UN agencies (US$) of 1971 in South Asia?
Offer a very short reply. 9.04e+06. What is the difference between the Aid flow from UN agencies (US$) in 1969 and Aid flow from UN agencies (US$) in 1970 in South Asia?
Offer a terse response. -2.95e+06. What is the difference between the Aid flow from UN agencies (US$) in 1969 and Aid flow from UN agencies (US$) in 1971 in South Asia?
Offer a terse response. -3.83e+06. What is the difference between the Aid flow from UN agencies (US$) of 1970 and Aid flow from UN agencies (US$) of 1971 in South Asia?
Your response must be concise. -8.80e+05. What is the ratio of the Aid flow from UN agencies (US$) of 1968 in Middle income to that in OECD members?
Offer a terse response. 19.94. What is the ratio of the Aid flow from UN agencies (US$) of 1969 in Middle income to that in OECD members?
Ensure brevity in your answer.  8.9. What is the ratio of the Aid flow from UN agencies (US$) in 1970 in Middle income to that in OECD members?
Your response must be concise. 9.38. What is the ratio of the Aid flow from UN agencies (US$) in 1971 in Middle income to that in OECD members?
Make the answer very short. 8.44. What is the ratio of the Aid flow from UN agencies (US$) of 1968 in Middle income to that in Other small states?
Give a very brief answer. 19.23. What is the ratio of the Aid flow from UN agencies (US$) of 1969 in Middle income to that in Other small states?
Ensure brevity in your answer.  30.08. What is the ratio of the Aid flow from UN agencies (US$) of 1970 in Middle income to that in Other small states?
Provide a succinct answer. 29.11. What is the ratio of the Aid flow from UN agencies (US$) in 1971 in Middle income to that in Other small states?
Your answer should be very brief. 28.61. What is the ratio of the Aid flow from UN agencies (US$) of 1968 in Middle income to that in Pacific island small states?
Offer a very short reply. 218.42. What is the ratio of the Aid flow from UN agencies (US$) in 1969 in Middle income to that in Pacific island small states?
Offer a terse response. 145.83. What is the ratio of the Aid flow from UN agencies (US$) of 1970 in Middle income to that in Pacific island small states?
Offer a very short reply. 102.14. What is the ratio of the Aid flow from UN agencies (US$) in 1971 in Middle income to that in Pacific island small states?
Your answer should be compact. 90.8. What is the ratio of the Aid flow from UN agencies (US$) of 1968 in Middle income to that in Small states?
Your response must be concise. 14.72. What is the ratio of the Aid flow from UN agencies (US$) in 1969 in Middle income to that in Small states?
Your answer should be very brief. 15.83. What is the ratio of the Aid flow from UN agencies (US$) of 1970 in Middle income to that in Small states?
Your response must be concise. 14.26. What is the ratio of the Aid flow from UN agencies (US$) in 1971 in Middle income to that in Small states?
Provide a short and direct response. 14.23. What is the ratio of the Aid flow from UN agencies (US$) in 1968 in Middle income to that in South Asia?
Offer a terse response. 5.07. What is the ratio of the Aid flow from UN agencies (US$) in 1969 in Middle income to that in South Asia?
Ensure brevity in your answer.  6.02. What is the ratio of the Aid flow from UN agencies (US$) of 1970 in Middle income to that in South Asia?
Your answer should be very brief. 6.04. What is the ratio of the Aid flow from UN agencies (US$) of 1971 in Middle income to that in South Asia?
Provide a short and direct response. 6.88. What is the ratio of the Aid flow from UN agencies (US$) of 1968 in OECD members to that in Other small states?
Make the answer very short. 0.96. What is the ratio of the Aid flow from UN agencies (US$) in 1969 in OECD members to that in Other small states?
Provide a succinct answer. 3.38. What is the ratio of the Aid flow from UN agencies (US$) of 1970 in OECD members to that in Other small states?
Give a very brief answer. 3.1. What is the ratio of the Aid flow from UN agencies (US$) of 1971 in OECD members to that in Other small states?
Your answer should be very brief. 3.39. What is the ratio of the Aid flow from UN agencies (US$) in 1968 in OECD members to that in Pacific island small states?
Your answer should be compact. 10.96. What is the ratio of the Aid flow from UN agencies (US$) of 1969 in OECD members to that in Pacific island small states?
Your response must be concise. 16.38. What is the ratio of the Aid flow from UN agencies (US$) in 1970 in OECD members to that in Pacific island small states?
Provide a succinct answer. 10.89. What is the ratio of the Aid flow from UN agencies (US$) in 1971 in OECD members to that in Pacific island small states?
Provide a short and direct response. 10.75. What is the ratio of the Aid flow from UN agencies (US$) in 1968 in OECD members to that in Small states?
Your answer should be compact. 0.74. What is the ratio of the Aid flow from UN agencies (US$) of 1969 in OECD members to that in Small states?
Keep it short and to the point. 1.78. What is the ratio of the Aid flow from UN agencies (US$) in 1970 in OECD members to that in Small states?
Your answer should be very brief. 1.52. What is the ratio of the Aid flow from UN agencies (US$) in 1971 in OECD members to that in Small states?
Your response must be concise. 1.69. What is the ratio of the Aid flow from UN agencies (US$) of 1968 in OECD members to that in South Asia?
Keep it short and to the point. 0.25. What is the ratio of the Aid flow from UN agencies (US$) of 1969 in OECD members to that in South Asia?
Your answer should be very brief. 0.68. What is the ratio of the Aid flow from UN agencies (US$) in 1970 in OECD members to that in South Asia?
Offer a terse response. 0.64. What is the ratio of the Aid flow from UN agencies (US$) of 1971 in OECD members to that in South Asia?
Your answer should be compact. 0.81. What is the ratio of the Aid flow from UN agencies (US$) in 1968 in Other small states to that in Pacific island small states?
Provide a succinct answer. 11.36. What is the ratio of the Aid flow from UN agencies (US$) in 1969 in Other small states to that in Pacific island small states?
Offer a terse response. 4.85. What is the ratio of the Aid flow from UN agencies (US$) in 1970 in Other small states to that in Pacific island small states?
Provide a short and direct response. 3.51. What is the ratio of the Aid flow from UN agencies (US$) in 1971 in Other small states to that in Pacific island small states?
Offer a very short reply. 3.17. What is the ratio of the Aid flow from UN agencies (US$) of 1968 in Other small states to that in Small states?
Ensure brevity in your answer.  0.77. What is the ratio of the Aid flow from UN agencies (US$) in 1969 in Other small states to that in Small states?
Your answer should be very brief. 0.53. What is the ratio of the Aid flow from UN agencies (US$) of 1970 in Other small states to that in Small states?
Your response must be concise. 0.49. What is the ratio of the Aid flow from UN agencies (US$) of 1971 in Other small states to that in Small states?
Ensure brevity in your answer.  0.5. What is the ratio of the Aid flow from UN agencies (US$) in 1968 in Other small states to that in South Asia?
Your answer should be compact. 0.26. What is the ratio of the Aid flow from UN agencies (US$) in 1969 in Other small states to that in South Asia?
Provide a succinct answer. 0.2. What is the ratio of the Aid flow from UN agencies (US$) of 1970 in Other small states to that in South Asia?
Your answer should be very brief. 0.21. What is the ratio of the Aid flow from UN agencies (US$) of 1971 in Other small states to that in South Asia?
Offer a terse response. 0.24. What is the ratio of the Aid flow from UN agencies (US$) of 1968 in Pacific island small states to that in Small states?
Your answer should be very brief. 0.07. What is the ratio of the Aid flow from UN agencies (US$) of 1969 in Pacific island small states to that in Small states?
Your answer should be compact. 0.11. What is the ratio of the Aid flow from UN agencies (US$) in 1970 in Pacific island small states to that in Small states?
Provide a short and direct response. 0.14. What is the ratio of the Aid flow from UN agencies (US$) of 1971 in Pacific island small states to that in Small states?
Provide a succinct answer. 0.16. What is the ratio of the Aid flow from UN agencies (US$) of 1968 in Pacific island small states to that in South Asia?
Offer a terse response. 0.02. What is the ratio of the Aid flow from UN agencies (US$) of 1969 in Pacific island small states to that in South Asia?
Give a very brief answer. 0.04. What is the ratio of the Aid flow from UN agencies (US$) in 1970 in Pacific island small states to that in South Asia?
Make the answer very short. 0.06. What is the ratio of the Aid flow from UN agencies (US$) in 1971 in Pacific island small states to that in South Asia?
Provide a short and direct response. 0.08. What is the ratio of the Aid flow from UN agencies (US$) in 1968 in Small states to that in South Asia?
Ensure brevity in your answer.  0.34. What is the ratio of the Aid flow from UN agencies (US$) of 1969 in Small states to that in South Asia?
Your answer should be very brief. 0.38. What is the ratio of the Aid flow from UN agencies (US$) of 1970 in Small states to that in South Asia?
Give a very brief answer. 0.42. What is the ratio of the Aid flow from UN agencies (US$) of 1971 in Small states to that in South Asia?
Give a very brief answer. 0.48. What is the difference between the highest and the second highest Aid flow from UN agencies (US$) in 1968?
Provide a succinct answer. 1.17e+08. What is the difference between the highest and the second highest Aid flow from UN agencies (US$) of 1969?
Offer a terse response. 8.03e+07. What is the difference between the highest and the second highest Aid flow from UN agencies (US$) of 1970?
Offer a terse response. 9.55e+07. What is the difference between the highest and the second highest Aid flow from UN agencies (US$) in 1971?
Your response must be concise. 1.16e+08. What is the difference between the highest and the lowest Aid flow from UN agencies (US$) of 1968?
Your answer should be very brief. 1.46e+08. What is the difference between the highest and the lowest Aid flow from UN agencies (US$) in 1969?
Offer a very short reply. 9.56e+07. What is the difference between the highest and the lowest Aid flow from UN agencies (US$) in 1970?
Make the answer very short. 1.13e+08. What is the difference between the highest and the lowest Aid flow from UN agencies (US$) of 1971?
Keep it short and to the point. 1.35e+08. 